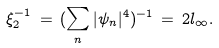<formula> <loc_0><loc_0><loc_500><loc_500>\xi _ { 2 } ^ { - 1 } \, = \, ( \sum _ { n } | \psi _ { n } | ^ { 4 } ) ^ { - 1 } \, = \, 2 l _ { \infty } .</formula> 